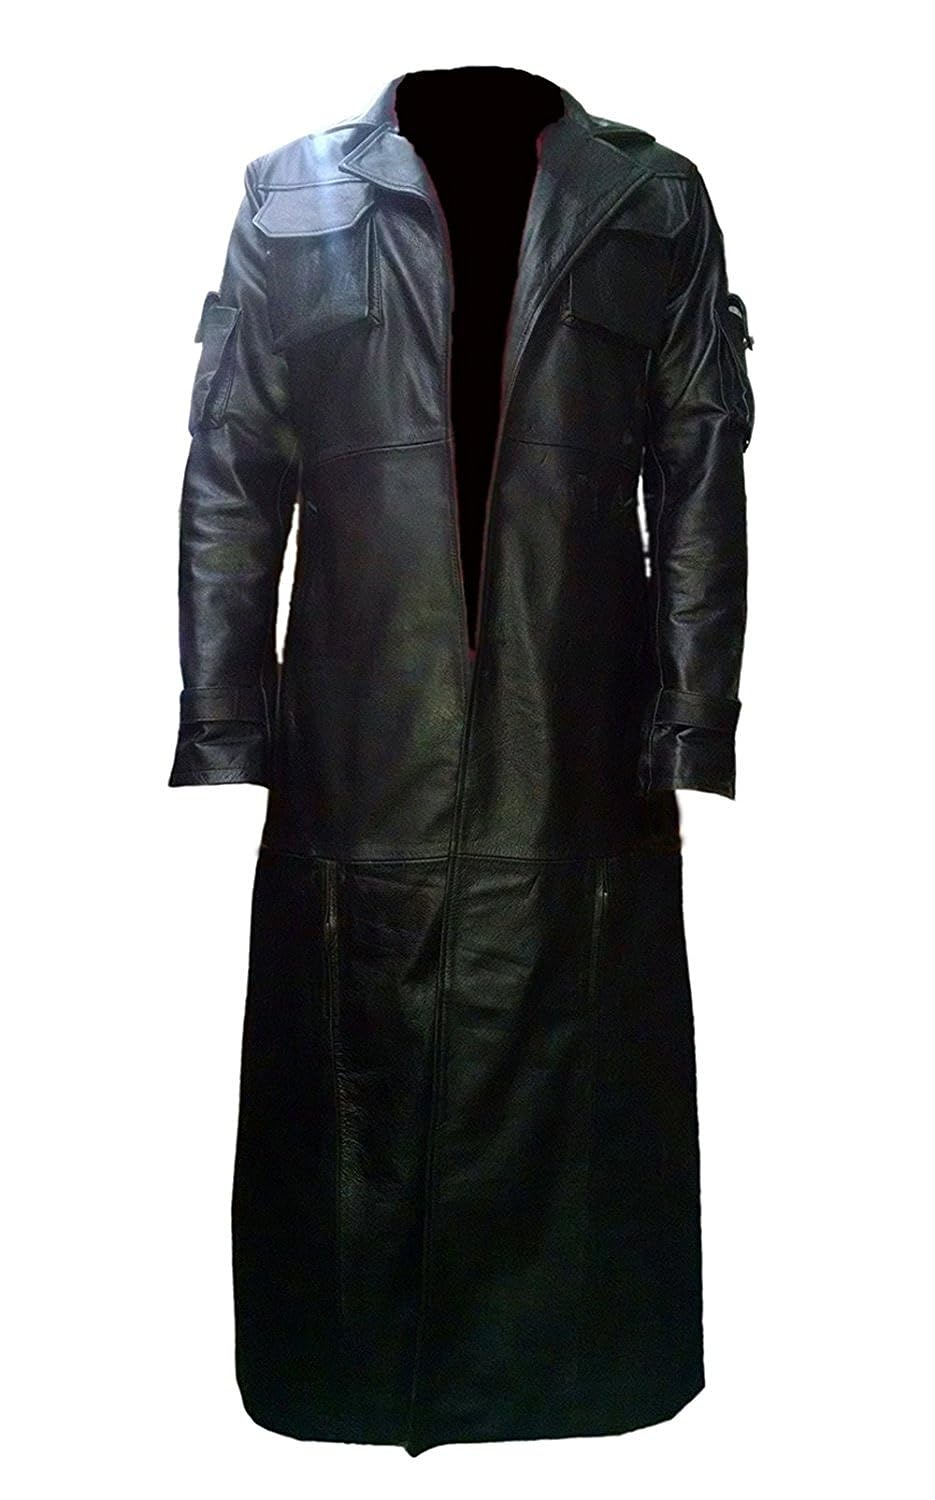What materials might be used in the construction of this coat, and how do they complement its overall style? This coat likely utilizes a high-grade leather, observed by the smooth texture and sheen visible in the image. Leather not only offers durability and protection from the elements but also adds a sleek, polished look that aligns with the coat's dramatic, elongated design. This material choice complements the strong, sculptural lines of the coat, reinforcing its impactful aesthetic which could be drawn from military or sophisticated urban styles. 
Could you explain how the coat's length influences its practicality or style? The considerable length of the coat enhances its style by creating an elegant, flowing silhouette that can make a striking statement in both fashion and cinematic contexts, suggesting a blend of regality and mystique. Practically, the length helps in providing extensive protection against cold and rain, making it a functional choice in colder climates while simultaneously elevating the wearer’s presence through its unique and imposing visual profile. 